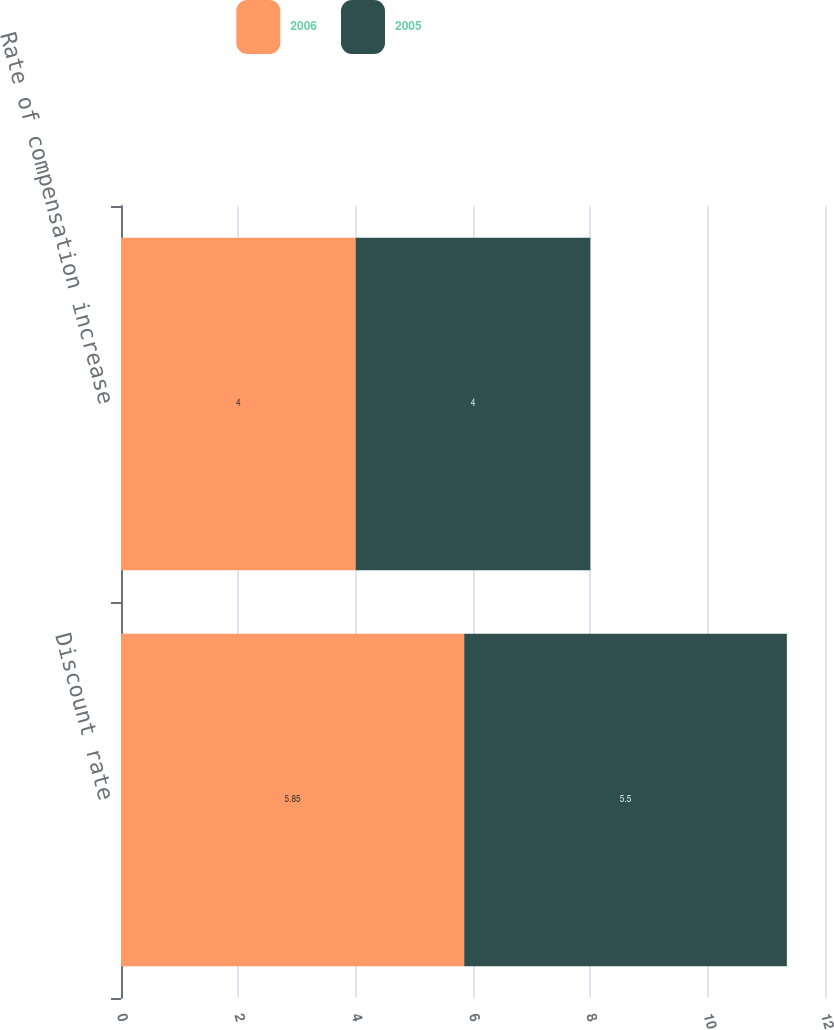<chart> <loc_0><loc_0><loc_500><loc_500><stacked_bar_chart><ecel><fcel>Discount rate<fcel>Rate of compensation increase<nl><fcel>2006<fcel>5.85<fcel>4<nl><fcel>2005<fcel>5.5<fcel>4<nl></chart> 